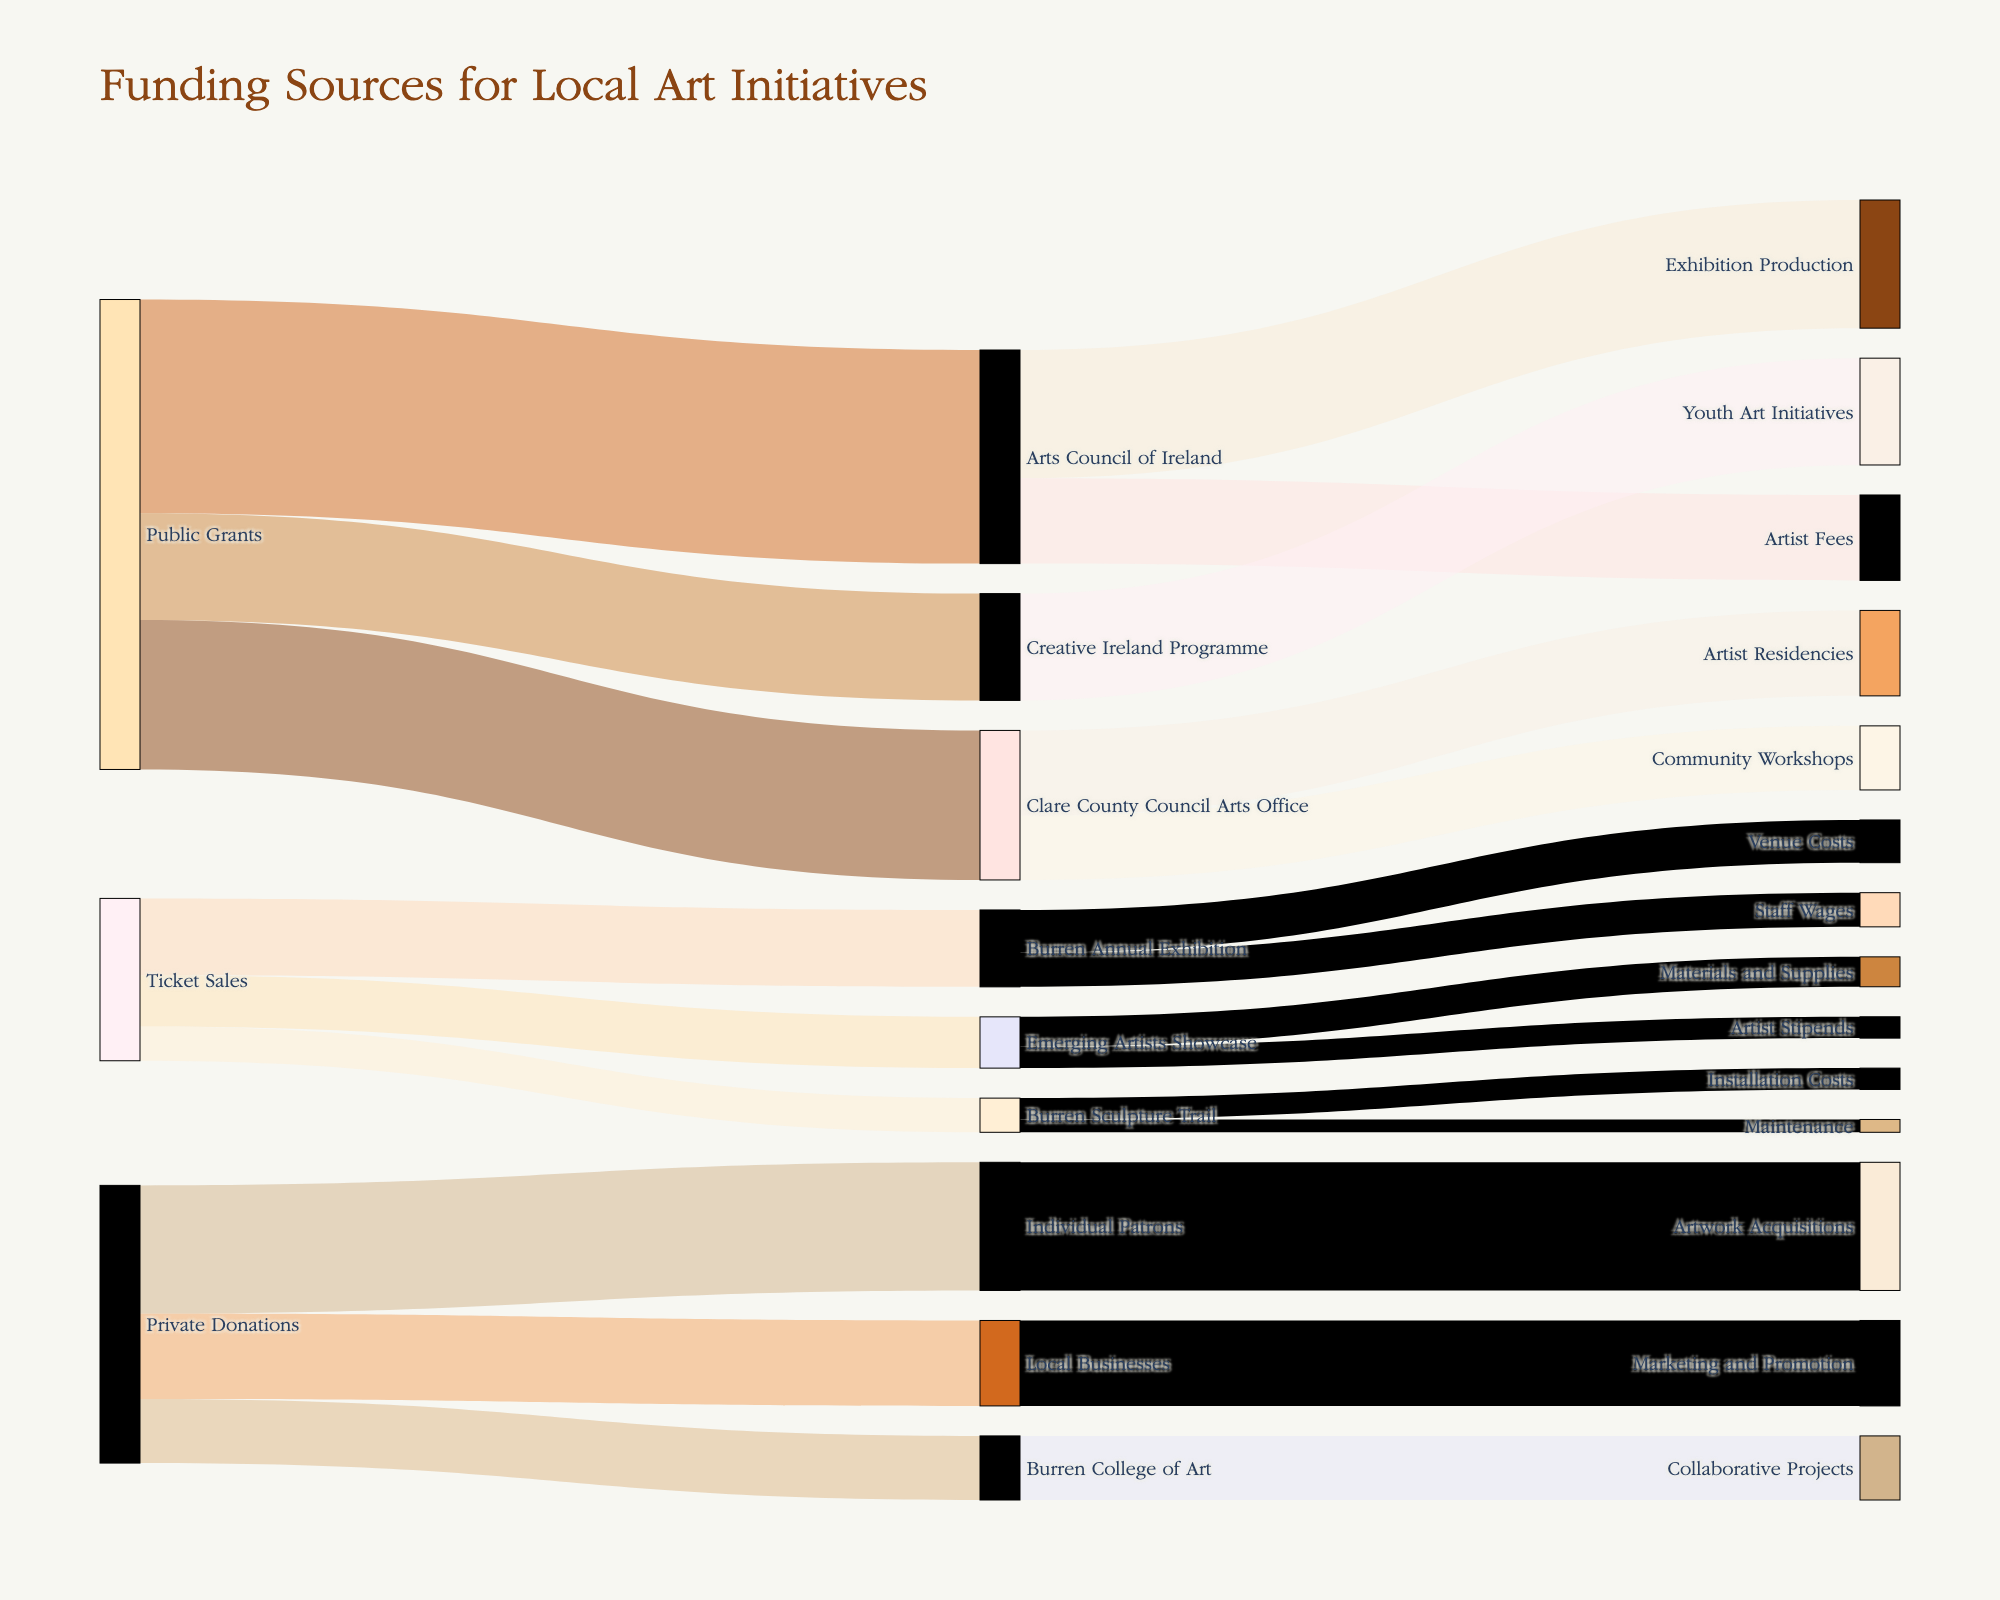Who is the largest source of funding for local art initiatives? By looking at the width of the paths from the different sources, we can see that the Arts Council of Ireland, receiving funds from Public Grants, provides the largest amount of funding with $50,000.
Answer: The Arts Council of Ireland Which local art initiative received the least funding from ticket sales? By comparing the paths leading to initiatives funded by ticket sales, the Burren Sculpture Trail received the least funding with $8,000.
Answer: Burren Sculpture Trail How much total funding does the Clare County Council Arts Office distribute, and to which initiatives? Clare County Council Arts Office distributes $35,000 in total: $20,000 to Artist Residencies and $15,000 to Community Workshops. Summing these amounts: $20,000 + $15,000 = $35,000.
Answer: $35,000 to Artist Residencies and Community Workshops Which initiative received the most funding from private donations and how much? By looking at contributions from private donations, Individual Patrons provided the highest donation to Artwork Acquisitions with $30,000.
Answer: Artwork Acquisitions, $30,000 Compare the total amount of funding received by initiatives from Public Grants versus Private Donations. Which is higher and by how much? Summing the values from Public Grants: $35,000 + $50,000 + $25,000 = $110,000. Summing the values from Private Donations: $15,000 + $20,000 + $30,000 = $65,000. Public Grants is higher: $110,000 - $65,000 = $45,000.
Answer: Public Grants by $45,000 Which funding source contributes to the most different types of initiatives, and how many types? Public Grants fund initiatives across five different categories: Clare County Council Arts Office, Arts Council of Ireland, Creative Ireland Programme, Burren Annual Exhibition, and Emerging Artists Showcase.
Answer: Public Grants, 5 types How much funding does the Creative Ireland Programme provide, and what initiative does it target? The Creative Ireland Programme provides $25,000, which is specifically targeted at Youth Art Initiatives.
Answer: $25,000 to Youth Art Initiatives What is the funding difference between the Marketing and Promotion and the Exhibition Production initiatives? The Marketing and Promotion initiative receives $20,000 from Local Businesses while the Exhibition Production initiative receives $30,000 from the Arts Council of Ireland. The difference is $30,000 - $20,000 = $10,000.
Answer: $10,000 How much is spent on Artist Fees by the Arts Council of Ireland and Emerging Artists Showcase combined? Arts Council of Ireland spends $20,000 on Artist Fees and the Emerging Artists Showcase spends $5,000 on Artist Stipends (similar to fees). Total: $20,000 + $5,000 = $25,000.
Answer: $25,000 What is the total amount of funding sourced from ticket sales, and how is it distributed across three events? Summing the values from Ticket Sales: $18,000 (Burren Annual Exhibition) + $12,000 (Emerging Artists Showcase) + $8,000 (Burren Sculpture Trail) = $38,000. Burren Annual Exhibition received $18,000, Emerging Artists Showcase $12,000, and Burren Sculpture Trail $8,000.
Answer: $38,000 distributed as $18,000, $12,000, and $8,000 